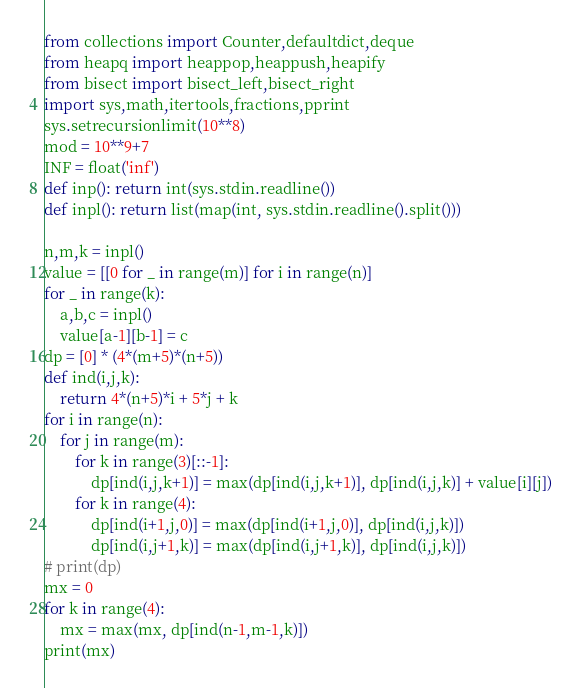Convert code to text. <code><loc_0><loc_0><loc_500><loc_500><_Python_>from collections import Counter,defaultdict,deque
from heapq import heappop,heappush,heapify
from bisect import bisect_left,bisect_right 
import sys,math,itertools,fractions,pprint
sys.setrecursionlimit(10**8)
mod = 10**9+7
INF = float('inf')
def inp(): return int(sys.stdin.readline())
def inpl(): return list(map(int, sys.stdin.readline().split()))

n,m,k = inpl()
value = [[0 for _ in range(m)] for i in range(n)]
for _ in range(k):
    a,b,c = inpl()
    value[a-1][b-1] = c
dp = [0] * (4*(m+5)*(n+5))
def ind(i,j,k): 
    return 4*(n+5)*i + 5*j + k
for i in range(n):
    for j in range(m):
        for k in range(3)[::-1]:
            dp[ind(i,j,k+1)] = max(dp[ind(i,j,k+1)], dp[ind(i,j,k)] + value[i][j])
        for k in range(4):
            dp[ind(i+1,j,0)] = max(dp[ind(i+1,j,0)], dp[ind(i,j,k)])
            dp[ind(i,j+1,k)] = max(dp[ind(i,j+1,k)], dp[ind(i,j,k)])
# print(dp)
mx = 0
for k in range(4):
    mx = max(mx, dp[ind(n-1,m-1,k)])
print(mx)</code> 